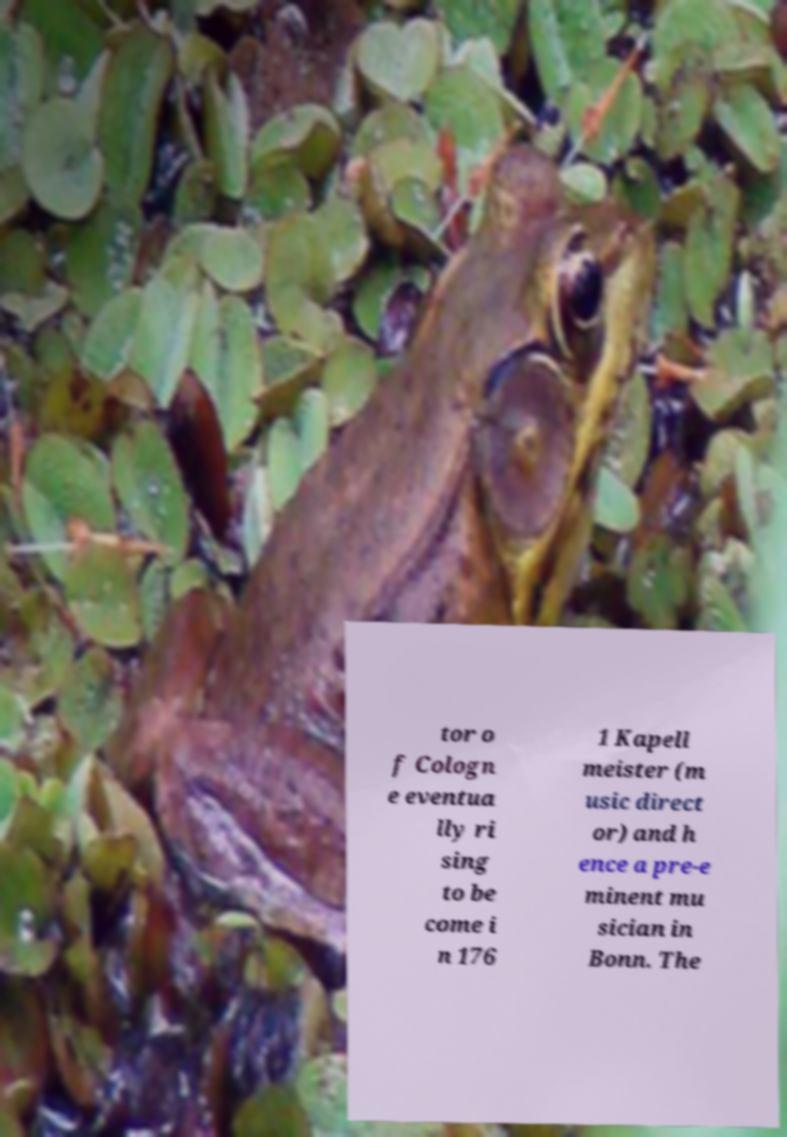Can you read and provide the text displayed in the image?This photo seems to have some interesting text. Can you extract and type it out for me? tor o f Cologn e eventua lly ri sing to be come i n 176 1 Kapell meister (m usic direct or) and h ence a pre-e minent mu sician in Bonn. The 